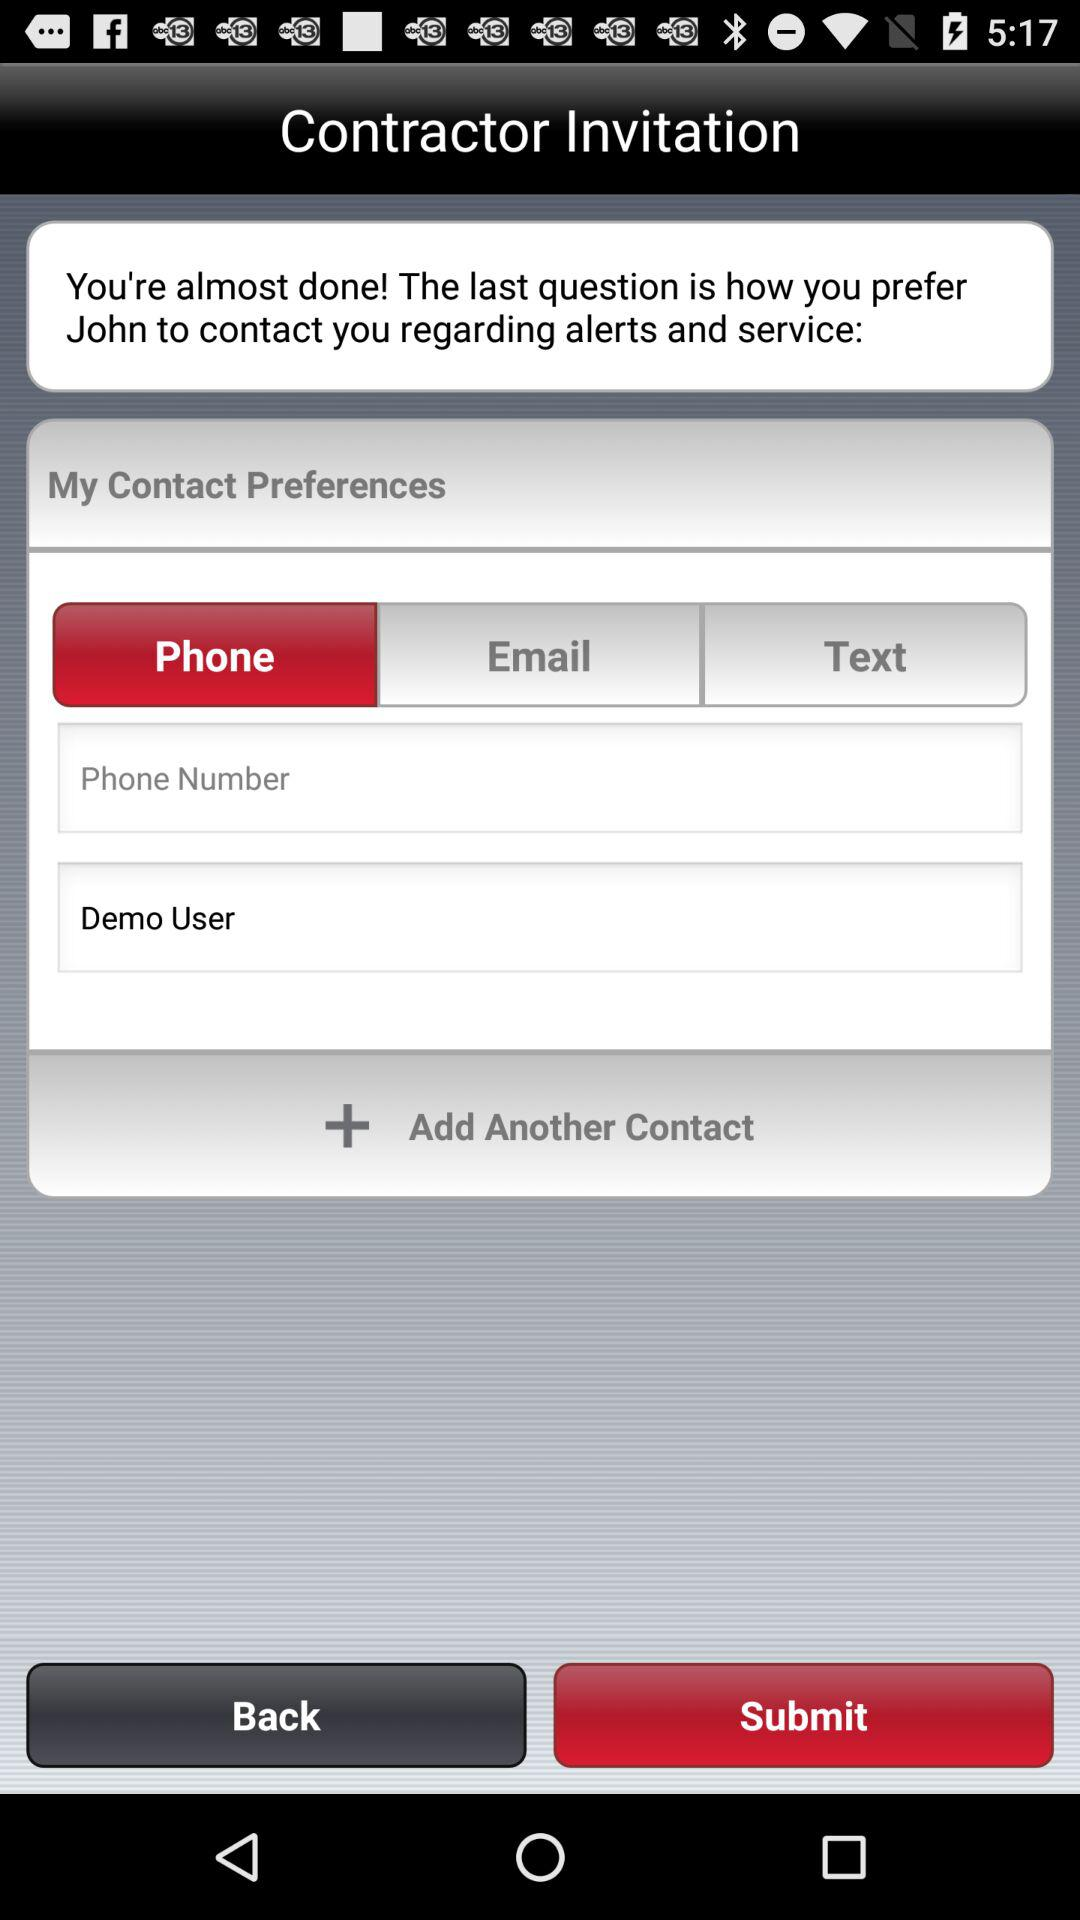How many contact preferences are available?
Answer the question using a single word or phrase. 3 